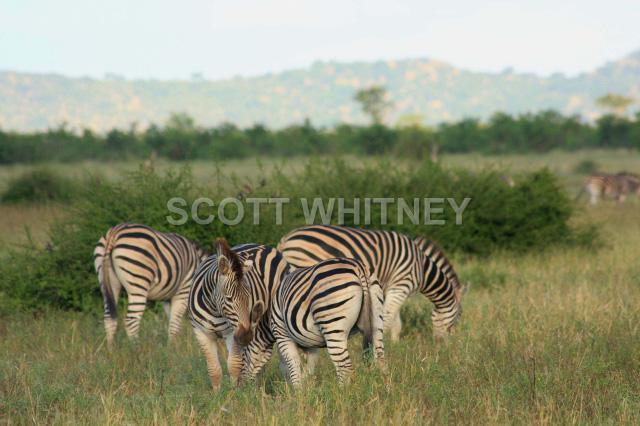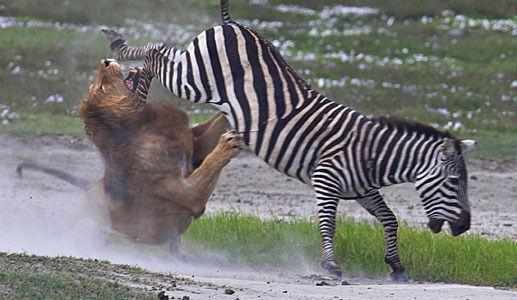The first image is the image on the left, the second image is the image on the right. Given the left and right images, does the statement "The right image contains one zebras being attacked by a lion." hold true? Answer yes or no. Yes. The first image is the image on the left, the second image is the image on the right. Assess this claim about the two images: "The right image shows a lion attacking from the back end of a zebra, with clouds of dust created by the struggle.". Correct or not? Answer yes or no. Yes. 